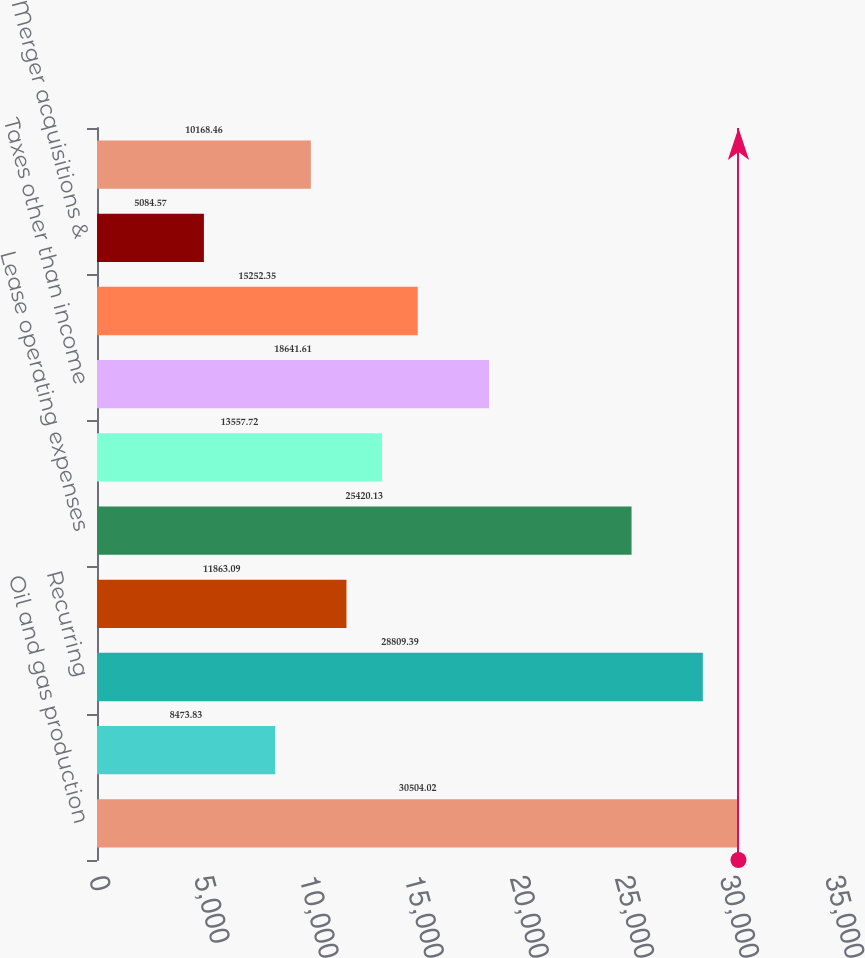Convert chart. <chart><loc_0><loc_0><loc_500><loc_500><bar_chart><fcel>Oil and gas production<fcel>Other<fcel>Recurring<fcel>Asset retirement obligation<fcel>Lease operating expenses<fcel>Gathering and transportation<fcel>Taxes other than income<fcel>General and administrative<fcel>Merger acquisitions &<fcel>Financing costs net<nl><fcel>30504<fcel>8473.83<fcel>28809.4<fcel>11863.1<fcel>25420.1<fcel>13557.7<fcel>18641.6<fcel>15252.4<fcel>5084.57<fcel>10168.5<nl></chart> 